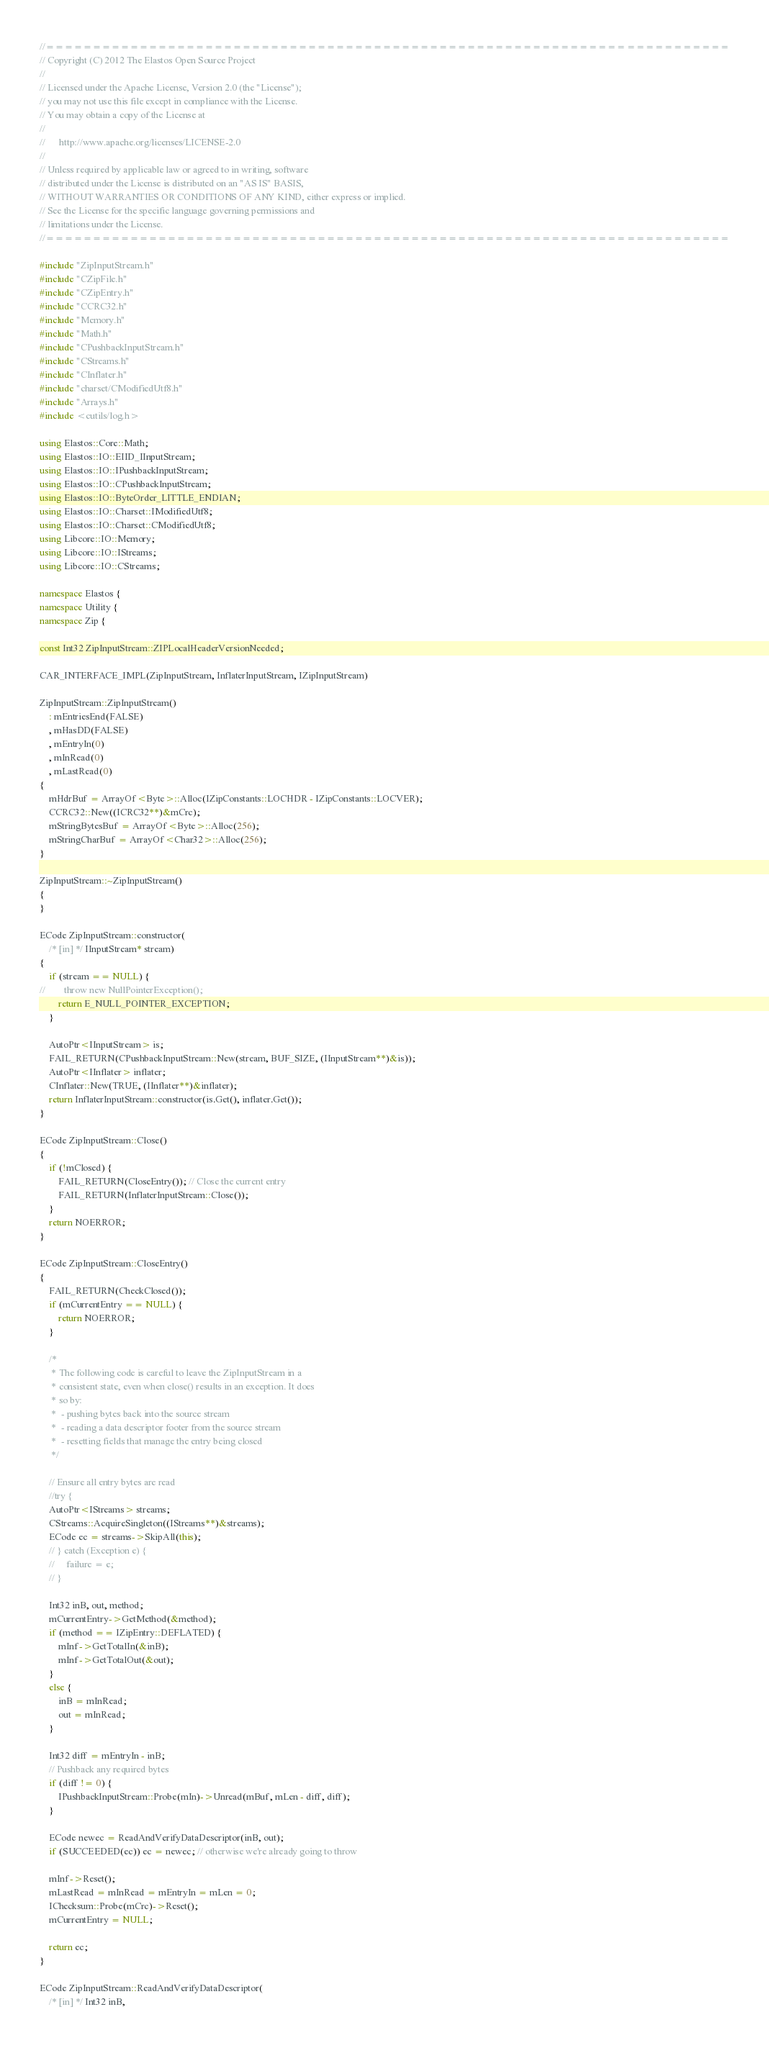<code> <loc_0><loc_0><loc_500><loc_500><_C++_>//=========================================================================
// Copyright (C) 2012 The Elastos Open Source Project
//
// Licensed under the Apache License, Version 2.0 (the "License");
// you may not use this file except in compliance with the License.
// You may obtain a copy of the License at
//
//      http://www.apache.org/licenses/LICENSE-2.0
//
// Unless required by applicable law or agreed to in writing, software
// distributed under the License is distributed on an "AS IS" BASIS,
// WITHOUT WARRANTIES OR CONDITIONS OF ANY KIND, either express or implied.
// See the License for the specific language governing permissions and
// limitations under the License.
//=========================================================================

#include "ZipInputStream.h"
#include "CZipFile.h"
#include "CZipEntry.h"
#include "CCRC32.h"
#include "Memory.h"
#include "Math.h"
#include "CPushbackInputStream.h"
#include "CStreams.h"
#include "CInflater.h"
#include "charset/CModifiedUtf8.h"
#include "Arrays.h"
#include <cutils/log.h>

using Elastos::Core::Math;
using Elastos::IO::EIID_IInputStream;
using Elastos::IO::IPushbackInputStream;
using Elastos::IO::CPushbackInputStream;
using Elastos::IO::ByteOrder_LITTLE_ENDIAN;
using Elastos::IO::Charset::IModifiedUtf8;
using Elastos::IO::Charset::CModifiedUtf8;
using Libcore::IO::Memory;
using Libcore::IO::IStreams;
using Libcore::IO::CStreams;

namespace Elastos {
namespace Utility {
namespace Zip {

const Int32 ZipInputStream::ZIPLocalHeaderVersionNeeded;

CAR_INTERFACE_IMPL(ZipInputStream, InflaterInputStream, IZipInputStream)

ZipInputStream::ZipInputStream()
    : mEntriesEnd(FALSE)
    , mHasDD(FALSE)
    , mEntryIn(0)
    , mInRead(0)
    , mLastRead(0)
{
    mHdrBuf = ArrayOf<Byte>::Alloc(IZipConstants::LOCHDR - IZipConstants::LOCVER);
    CCRC32::New((ICRC32**)&mCrc);
    mStringBytesBuf = ArrayOf<Byte>::Alloc(256);
    mStringCharBuf = ArrayOf<Char32>::Alloc(256);
}

ZipInputStream::~ZipInputStream()
{
}

ECode ZipInputStream::constructor(
    /* [in] */ IInputStream* stream)
{
    if (stream == NULL) {
//        throw new NullPointerException();
        return E_NULL_POINTER_EXCEPTION;
    }

    AutoPtr<IInputStream> is;
    FAIL_RETURN(CPushbackInputStream::New(stream, BUF_SIZE, (IInputStream**)&is));
    AutoPtr<IInflater> inflater;
    CInflater::New(TRUE, (IInflater**)&inflater);
    return InflaterInputStream::constructor(is.Get(), inflater.Get());
}

ECode ZipInputStream::Close()
{
    if (!mClosed) {
        FAIL_RETURN(CloseEntry()); // Close the current entry
        FAIL_RETURN(InflaterInputStream::Close());
    }
    return NOERROR;
}

ECode ZipInputStream::CloseEntry()
{
    FAIL_RETURN(CheckClosed());
    if (mCurrentEntry == NULL) {
        return NOERROR;
    }

    /*
     * The following code is careful to leave the ZipInputStream in a
     * consistent state, even when close() results in an exception. It does
     * so by:
     *  - pushing bytes back into the source stream
     *  - reading a data descriptor footer from the source stream
     *  - resetting fields that manage the entry being closed
     */

    // Ensure all entry bytes are read
    //try {
    AutoPtr<IStreams> streams;
    CStreams::AcquireSingleton((IStreams**)&streams);
    ECode ec = streams->SkipAll(this);
    // } catch (Exception e) {
    //     failure = e;
    // }

    Int32 inB, out, method;
    mCurrentEntry->GetMethod(&method);
    if (method == IZipEntry::DEFLATED) {
        mInf->GetTotalIn(&inB);
        mInf->GetTotalOut(&out);
    }
    else {
        inB = mInRead;
        out = mInRead;
    }

    Int32 diff = mEntryIn - inB;
    // Pushback any required bytes
    if (diff != 0) {
        IPushbackInputStream::Probe(mIn)->Unread(mBuf, mLen - diff, diff);
    }

    ECode newec = ReadAndVerifyDataDescriptor(inB, out);
    if (SUCCEEDED(ec)) ec = newec; // otherwise we're already going to throw

    mInf->Reset();
    mLastRead = mInRead = mEntryIn = mLen = 0;
    IChecksum::Probe(mCrc)->Reset();
    mCurrentEntry = NULL;

    return ec;
}

ECode ZipInputStream::ReadAndVerifyDataDescriptor(
    /* [in] */ Int32 inB,</code> 